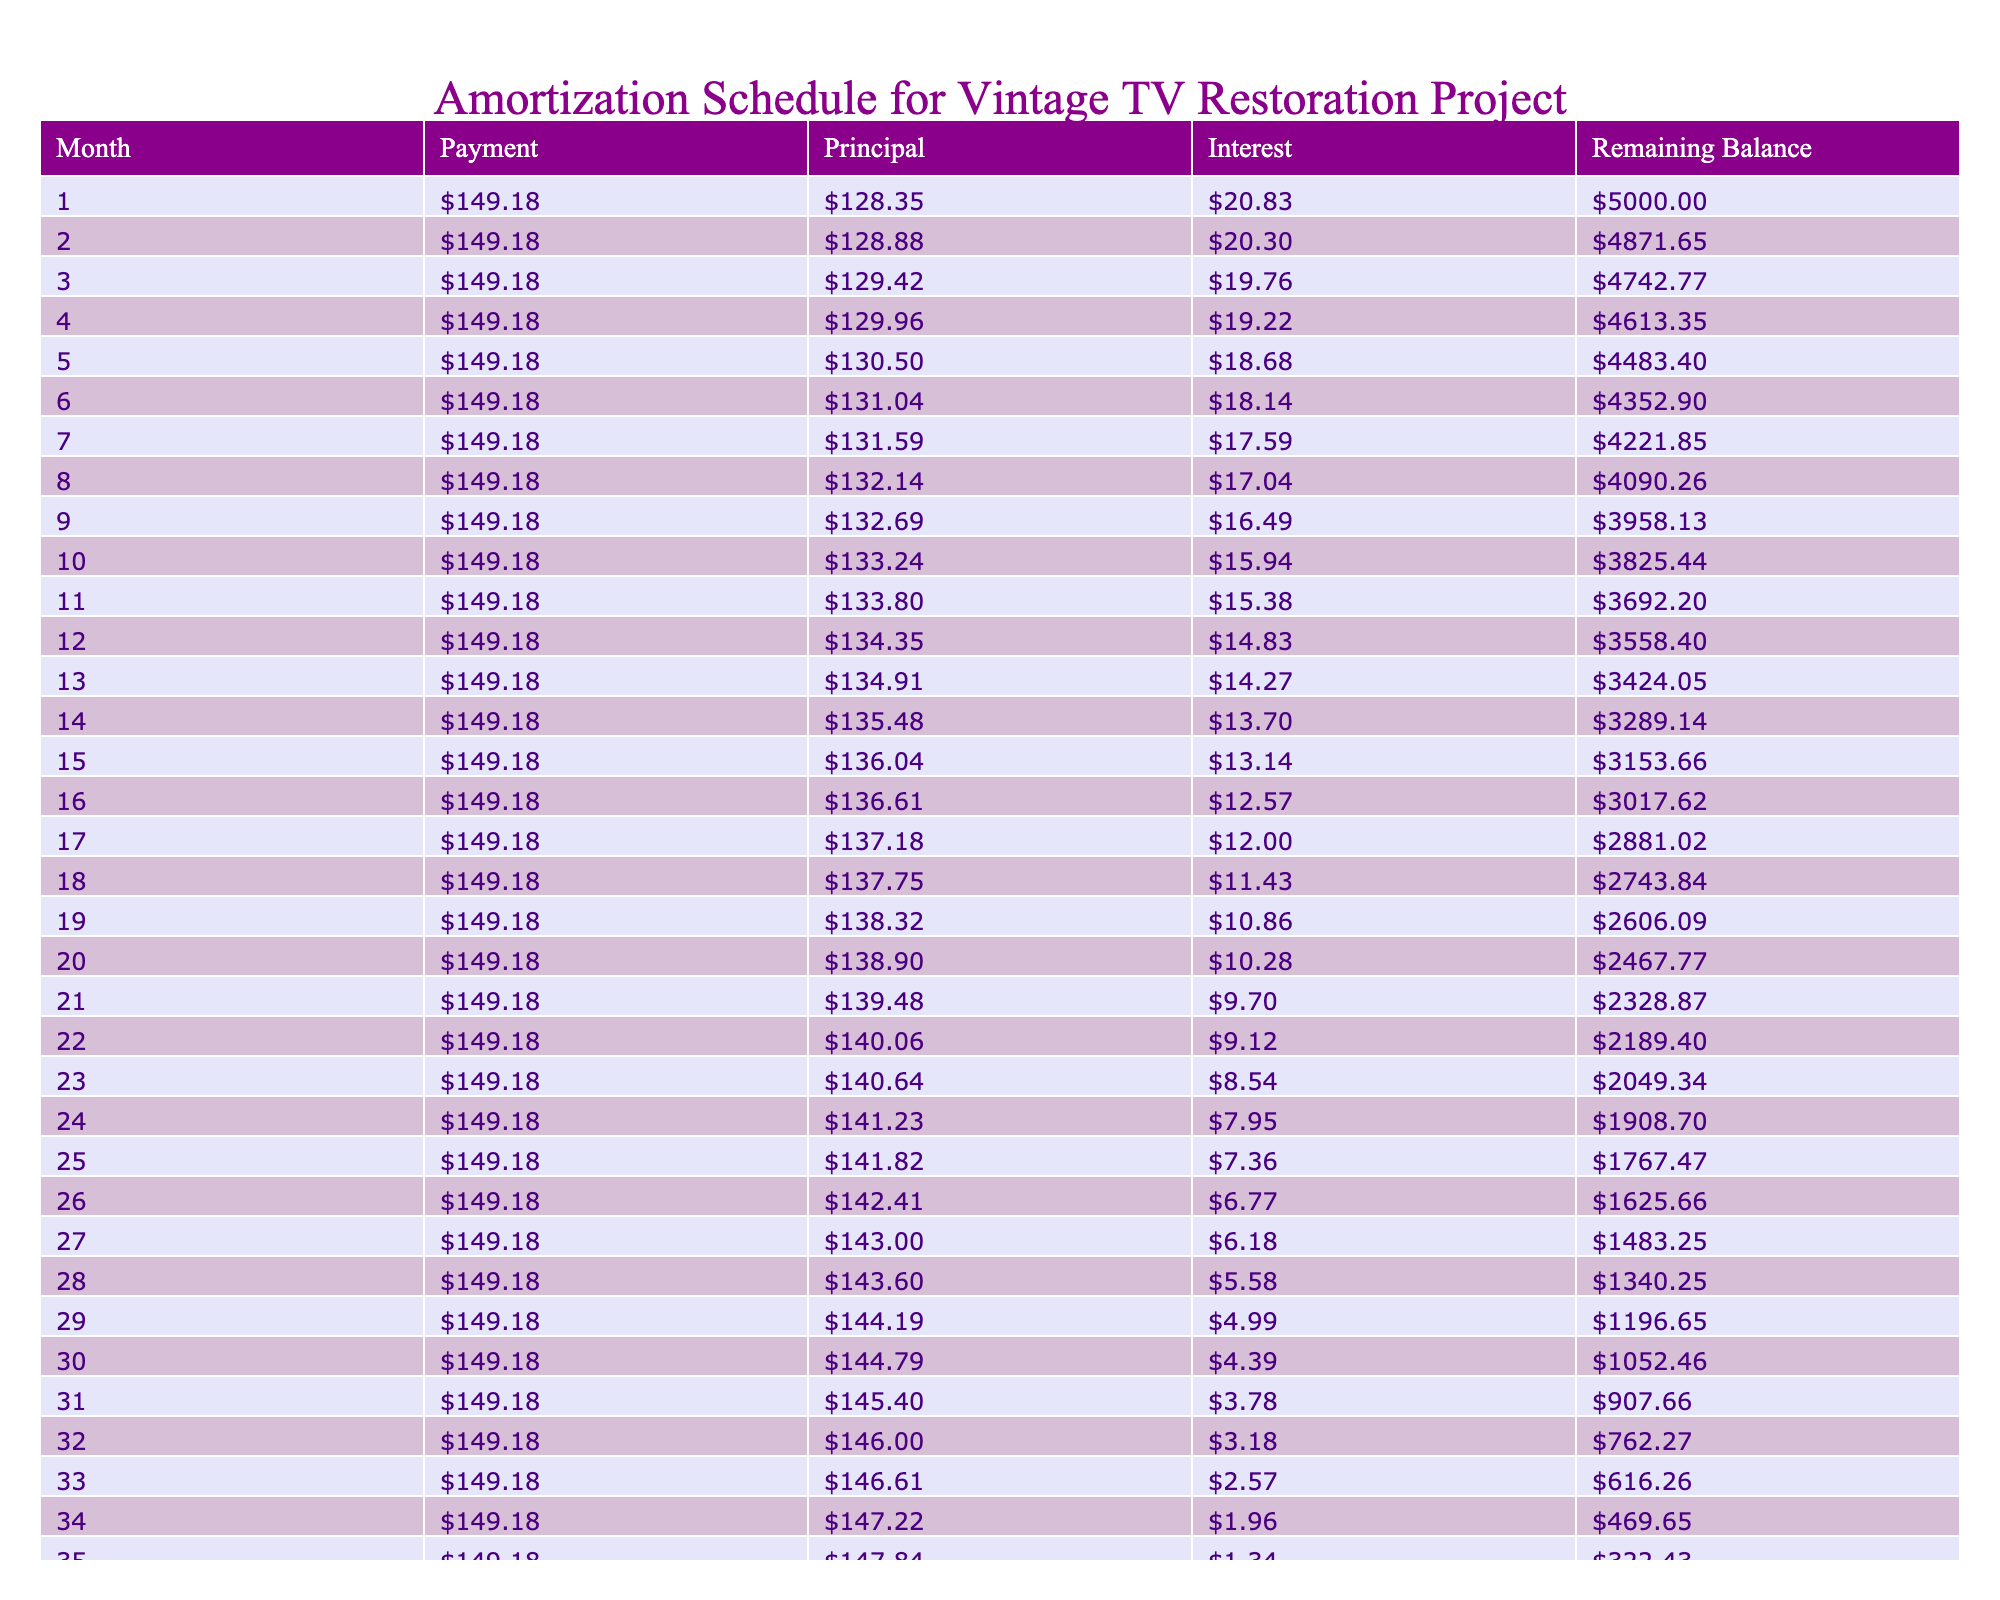What is the total amount paid by the end of the loan term? The total payment is directly included in the table, displayed under the "Total Payment" column. It lists the total amount the borrower will pay over the entire term of the loan.
Answer: 5369.48 How much is the monthly payment for this loan? The monthly payment is also provided in the table under the "Monthly Payment" column, indicating the amount that is due each month for the duration of the loan.
Answer: 149.18 What is the total interest paid over the entire loan period? The total interest paid is shown in the "Total Interest" column of the table. This value represents the total cost of borrowing over the period of the loan, calculated as the difference between the total payment and the loan amount.
Answer: 369.48 Is the monthly payment higher than the average interest payment per month? To determine this, first, we need to find the average monthly interest payment by dividing the total interest by the loan term (36 months). The average monthly interest payment is 369.48 / 36 = 10.27. Since the monthly payment of 149.18 is greater than 10.27, the answer is yes.
Answer: Yes What is the remaining balance after the first month? The remaining balance can be found by looking at the "Remaining Balance" column for the first month, which shows how much of the original loan amount is left after the first payment has been made.
Answer: 4850.82 How much of the total payment goes toward interest over the loan term? By dividing the total interest by the total payment, we can find what fraction of the total payment is interest. The fraction is 369.48 / 5369.48 = 0.0688 or approximately 6.88%. This indicates how much of the total payment is allocated to interest.
Answer: 6.88% What is the total principal paid by the end of the loan term? The total principal can be calculated by taking the loan amount and subtracting the total interest from the total payment. This gives the total principal paid over the loan term, which can be confirmed by adding all principal payments.
Answer: 4630.52 Does the initial loan amount remain the same throughout the loan term? As the loan gets repaid each month, the remaining balance decreases with each monthly payment. A quick examination of the "Remaining Balance" column shows it goes from 5000 to 0 over the loan term, indicating that the initial amount does not remain the same.
Answer: No What is the difference between the total payment and total interest? This is calculated by subtracting the total interest from the total payment: 5369.48 - 369.48 = 5000. This result represents the total principal amount paid by the borrower, confirming that the loan is repaid in full over the term.
Answer: 5000 